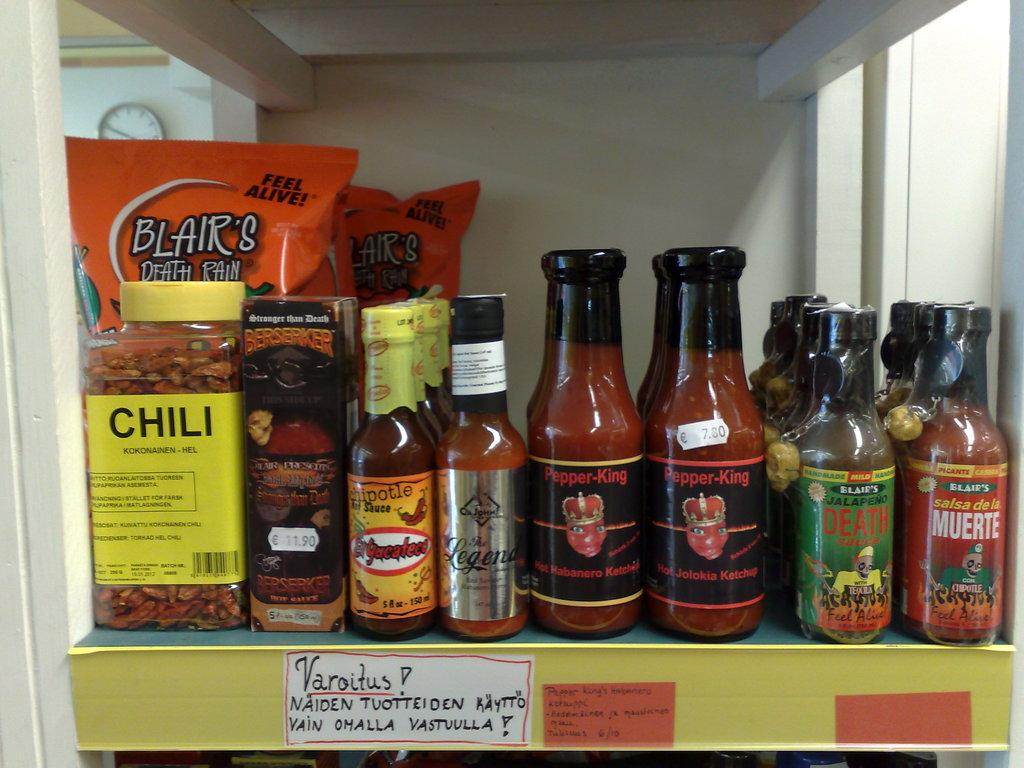<image>
Share a concise interpretation of the image provided. An assortment of hot pepper condiments, including Blair's hot sauce, sit on a store shelf. 